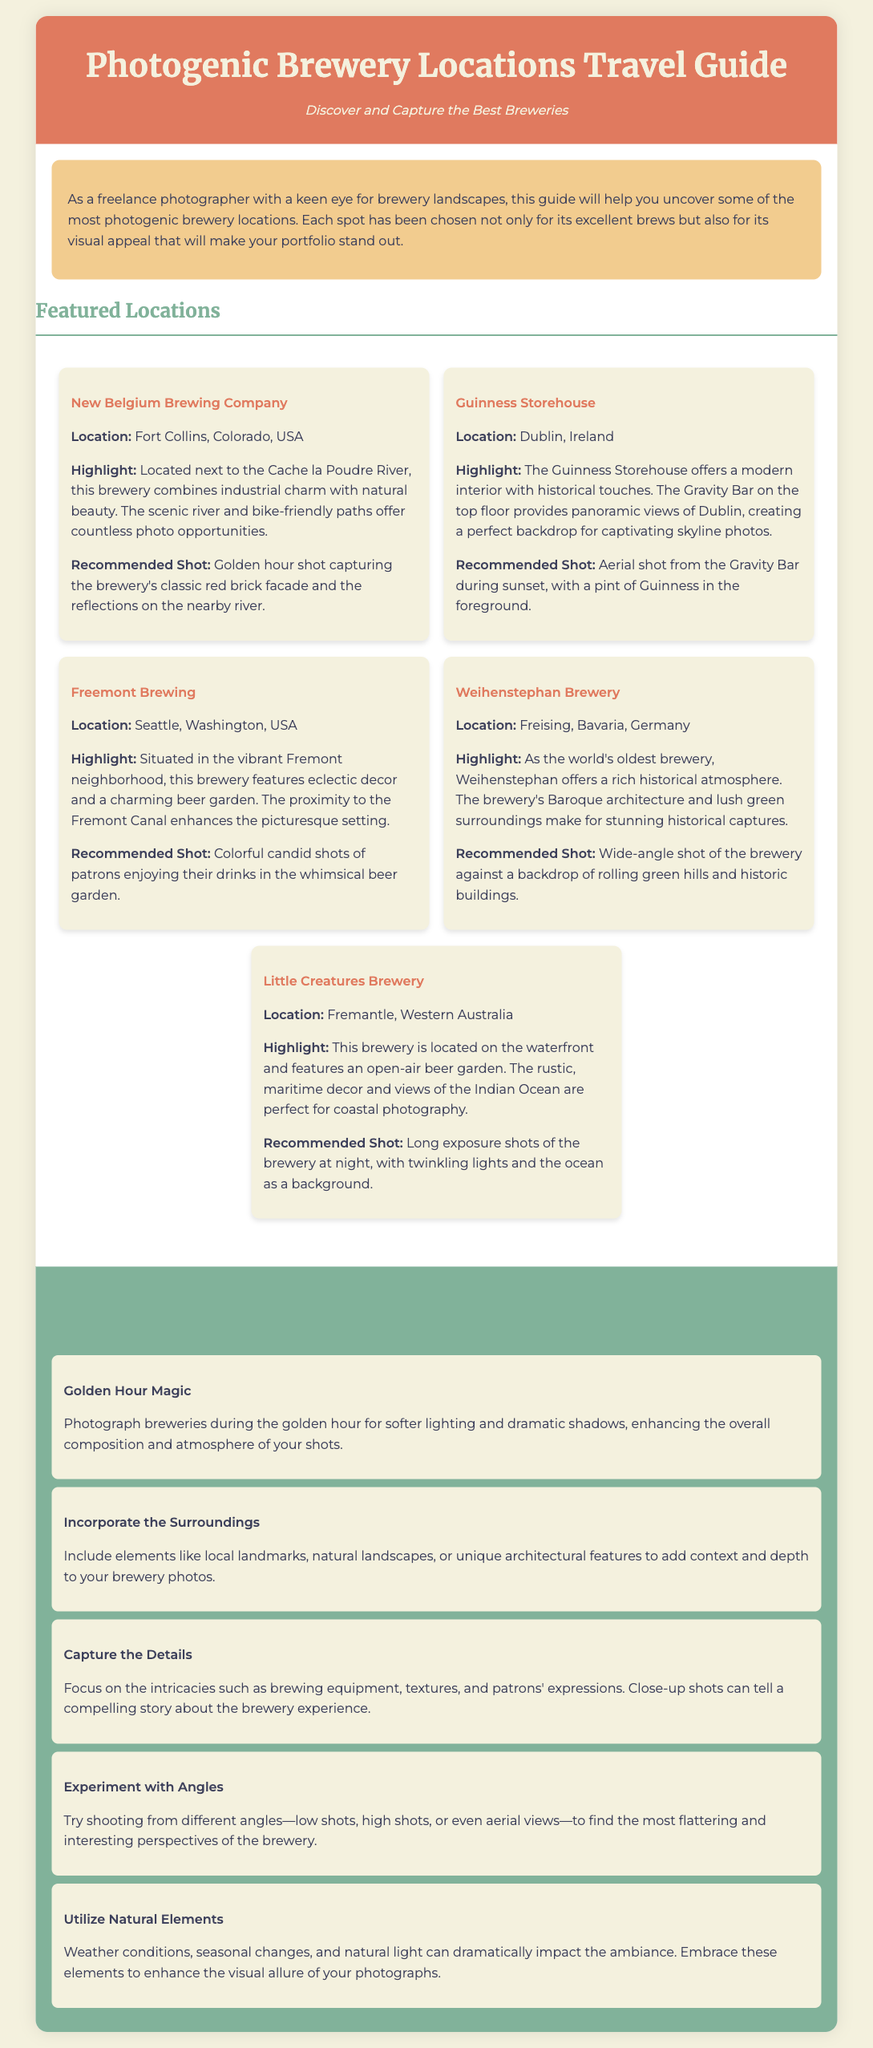What is the title of the document? The title of the document is displayed prominently at the top, indicating the focus of the guide.
Answer: Photogenic Brewery Locations Travel Guide Where is New Belgium Brewing Company located? The location for each brewery is specified in the respective location cards within the document.
Answer: Fort Collins, Colorado, USA What is the highlight of the Guinness Storehouse? The highlights for each location are provided to showcase their unique features and appeals.
Answer: Panoramic views of Dublin What photography tip emphasizes shooting times? This document contains tips specifically tailored to improve photography skills, mentioning optimal times or techniques.
Answer: Golden Hour Magic What is recommended to include in brewery photos? The document suggests elements to enhance the composition in photography, promoting context and depth in images.
Answer: Incorporate the Surroundings How many recommended shots are listed for Little Creatures Brewery? By analyzing the content under each brewery, we can determine the number of distinct photography suggestions provided.
Answer: One What kind of architecture is noted at Weihenstephan Brewery? Specific architectural styles or features are mentioned to highlight the brewery's visual appeal and historical significance.
Answer: Baroque architecture What natural feature is mentioned at Freemont Brewing? The document specifies certain natural settings or local elements that enhance the brewing experience or scenery.
Answer: Fremont Canal Which brewery is noted for its waterfront location? The guide identifies unique features of each brewery, including geographical attributes related to water bodies.
Answer: Little Creatures Brewery 